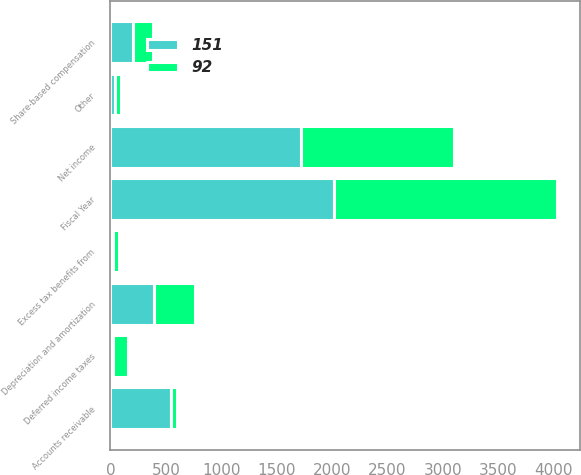Convert chart. <chart><loc_0><loc_0><loc_500><loc_500><stacked_bar_chart><ecel><fcel>Fiscal Year<fcel>Net income<fcel>Depreciation and amortization<fcel>Excess tax benefits from<fcel>Deferred income taxes<fcel>Other<fcel>Share-based compensation<fcel>Accounts receivable<nl><fcel>151<fcel>2016<fcel>1721<fcel>389<fcel>23<fcel>21<fcel>38<fcel>201<fcel>542<nl><fcel>92<fcel>2015<fcel>1377<fcel>371<fcel>56<fcel>134<fcel>53<fcel>187<fcel>61<nl></chart> 